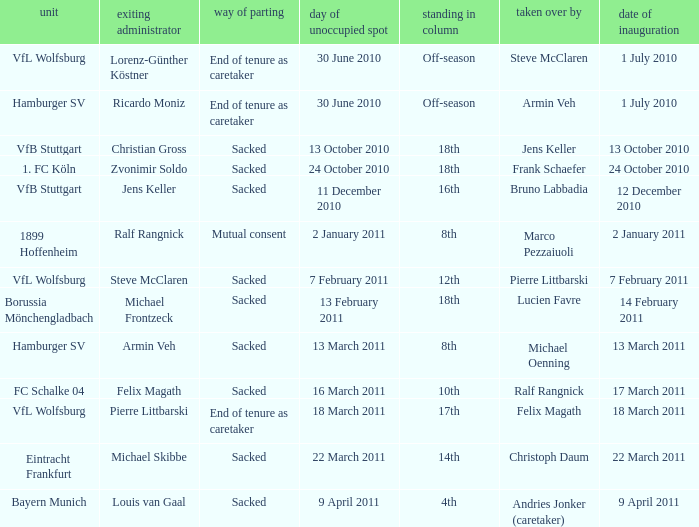When 1. fc köln is the team what is the date of appointment? 24 October 2010. 